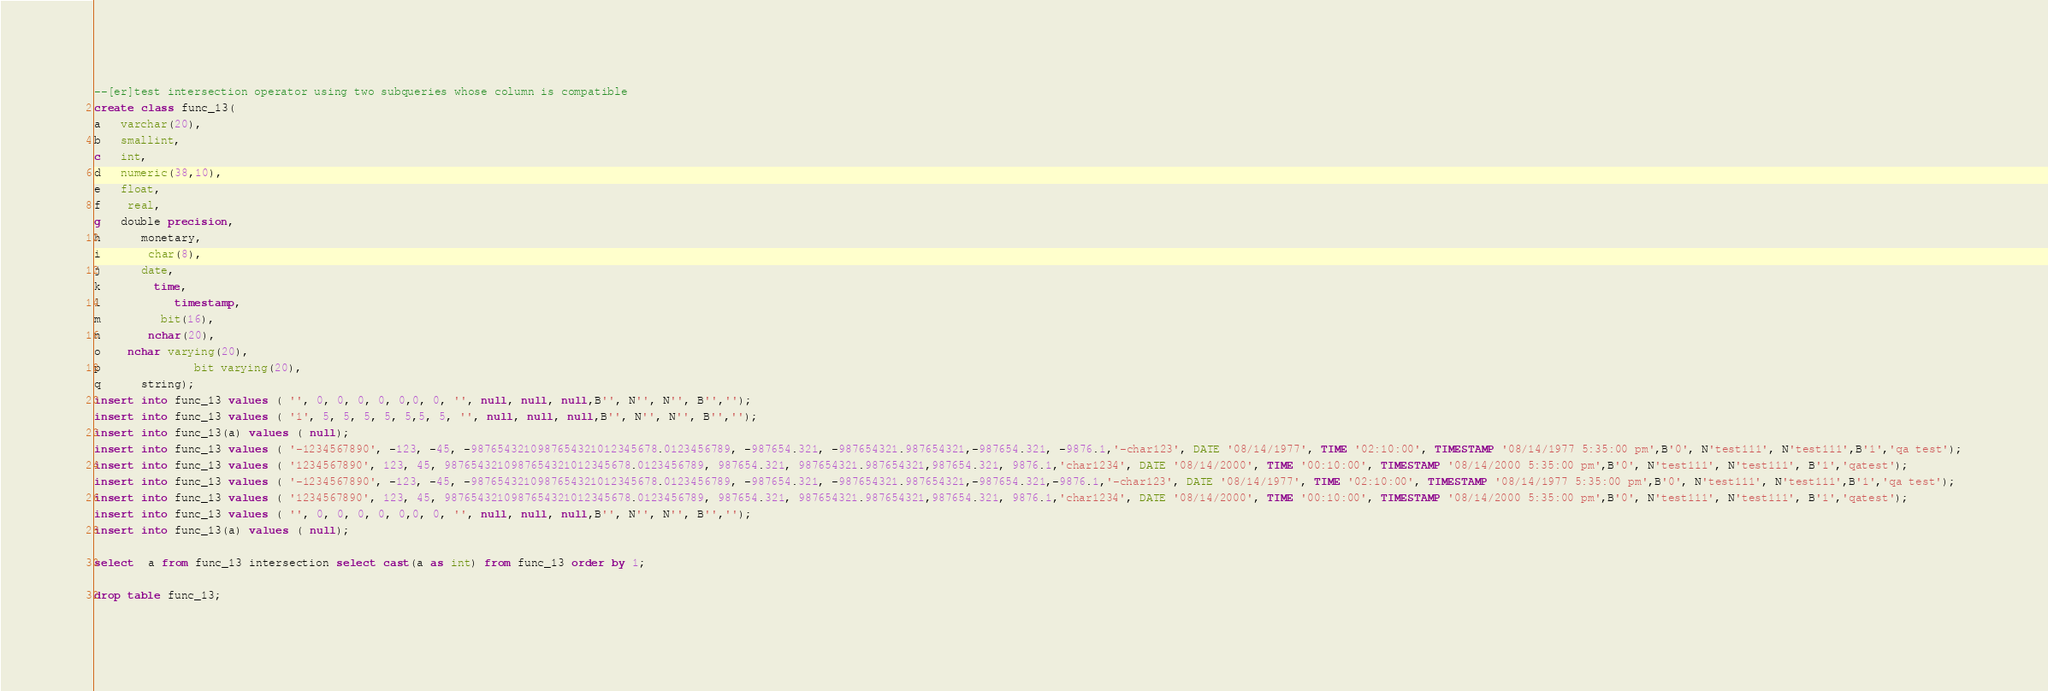Convert code to text. <code><loc_0><loc_0><loc_500><loc_500><_SQL_>--[er]test intersection operator using two subqueries whose column is compatible
create class func_13(
a   varchar(20),
b   smallint,
c   int,
d   numeric(38,10),
e   float,
f    real,
g   double precision,
h      monetary,
i       char(8),
j      date,
k        time,
l           timestamp,
m         bit(16),
n       nchar(20),
o    nchar varying(20),
p              bit varying(20),
q      string);
insert into func_13 values ( '', 0, 0, 0, 0, 0,0, 0, '', null, null, null,B'', N'', N'', B'','');
insert into func_13 values ( '1', 5, 5, 5, 5, 5,5, 5, '', null, null, null,B'', N'', N'', B'','');
insert into func_13(a) values ( null);
insert into func_13 values ( '-1234567890', -123, -45, -9876543210987654321012345678.0123456789, -987654.321, -987654321.987654321,-987654.321, -9876.1,'-char123', DATE '08/14/1977', TIME '02:10:00', TIMESTAMP '08/14/1977 5:35:00 pm',B'0', N'test111', N'test111',B'1','qa test');
insert into func_13 values ( '1234567890', 123, 45, 9876543210987654321012345678.0123456789, 987654.321, 987654321.987654321,987654.321, 9876.1,'char1234', DATE '08/14/2000', TIME '00:10:00', TIMESTAMP '08/14/2000 5:35:00 pm',B'0', N'test111', N'test111', B'1','qatest');
insert into func_13 values ( '-1234567890', -123, -45, -9876543210987654321012345678.0123456789, -987654.321, -987654321.987654321,-987654.321,-9876.1,'-char123', DATE '08/14/1977', TIME '02:10:00', TIMESTAMP '08/14/1977 5:35:00 pm',B'0', N'test111', N'test111',B'1','qa test');
insert into func_13 values ( '1234567890', 123, 45, 9876543210987654321012345678.0123456789, 987654.321, 987654321.987654321,987654.321, 9876.1,'char1234', DATE '08/14/2000', TIME '00:10:00', TIMESTAMP '08/14/2000 5:35:00 pm',B'0', N'test111', N'test111', B'1','qatest');
insert into func_13 values ( '', 0, 0, 0, 0, 0,0, 0, '', null, null, null,B'', N'', N'', B'','');
insert into func_13(a) values ( null);

select  a from func_13 intersection select cast(a as int) from func_13 order by 1;

drop table func_13;

</code> 